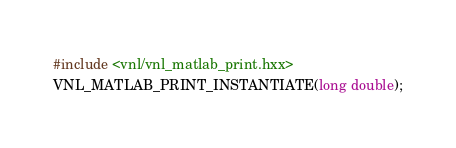Convert code to text. <code><loc_0><loc_0><loc_500><loc_500><_C++_>#include <vnl/vnl_matlab_print.hxx>
VNL_MATLAB_PRINT_INSTANTIATE(long double);
</code> 